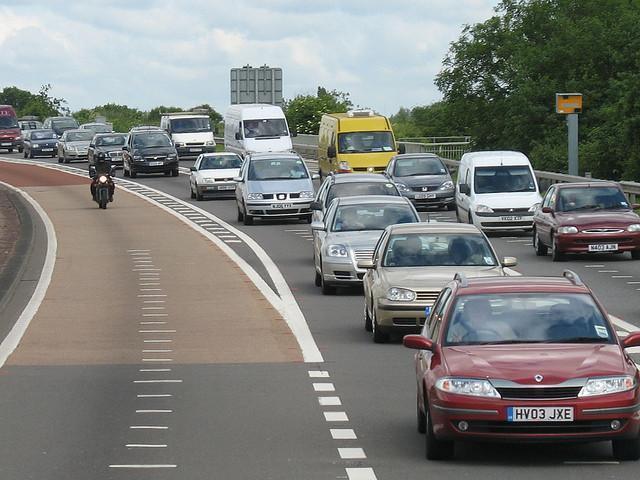Who are the roads for?
From the following set of four choices, select the accurate answer to respond to the question.
Options: Drivers, pedestrians, downtown, directions. Drivers. 